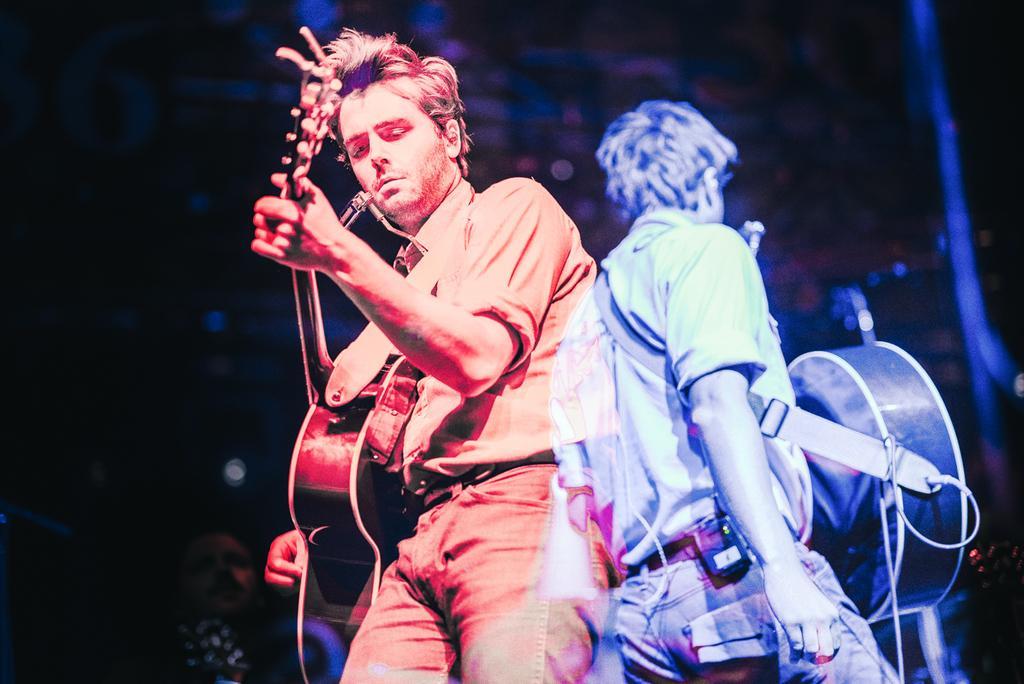Could you give a brief overview of what you see in this image? Two persons playing guitar. 